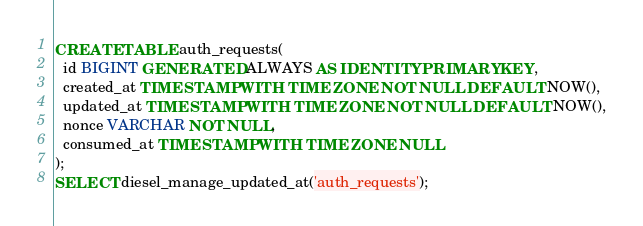Convert code to text. <code><loc_0><loc_0><loc_500><loc_500><_SQL_>CREATE TABLE auth_requests(
  id BIGINT GENERATED ALWAYS AS IDENTITY PRIMARY KEY,
  created_at TIMESTAMP WITH TIME ZONE NOT NULL DEFAULT NOW(),
  updated_at TIMESTAMP WITH TIME ZONE NOT NULL DEFAULT NOW(),
  nonce VARCHAR NOT NULL,
  consumed_at TIMESTAMP WITH TIME ZONE NULL
);
SELECT diesel_manage_updated_at('auth_requests');
</code> 